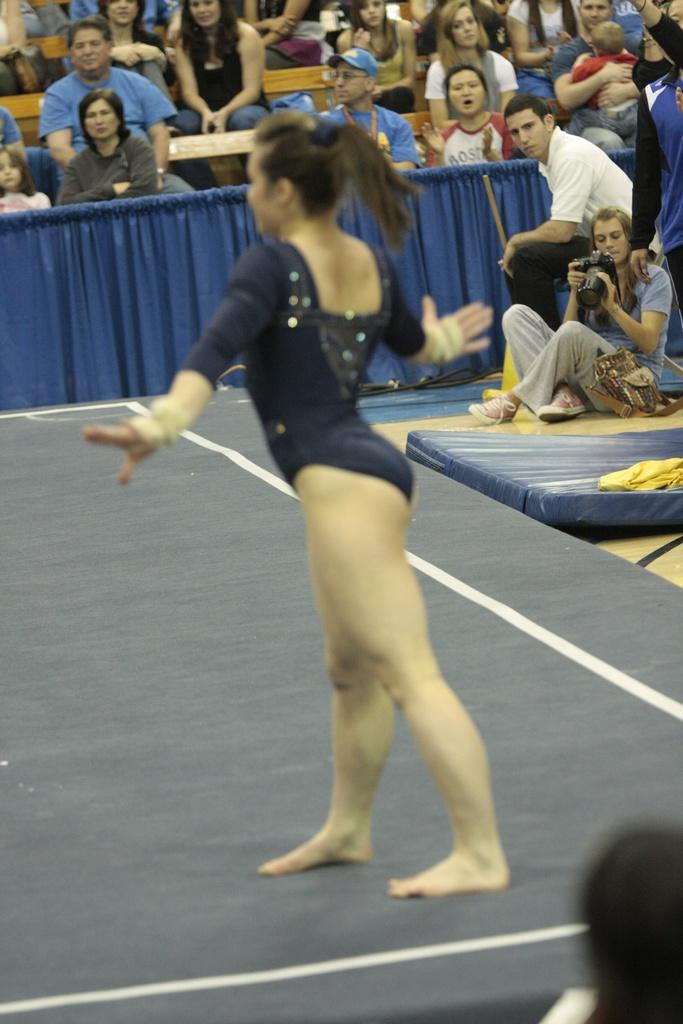What is the main subject of the image? There is a person standing in the image. What else can be seen in the image besides the person? There is a table, chairs, and a group of persons in the image. Can you describe the object on the right side of the image? There is an object on a surface on the right side of the image. What type of cloth is draped over the roof in the image? There is no roof or cloth present in the image. Can you describe the robin perched on the chair in the image? There is no robin present in the image; only a person, table, chairs, and a group of persons are visible. 